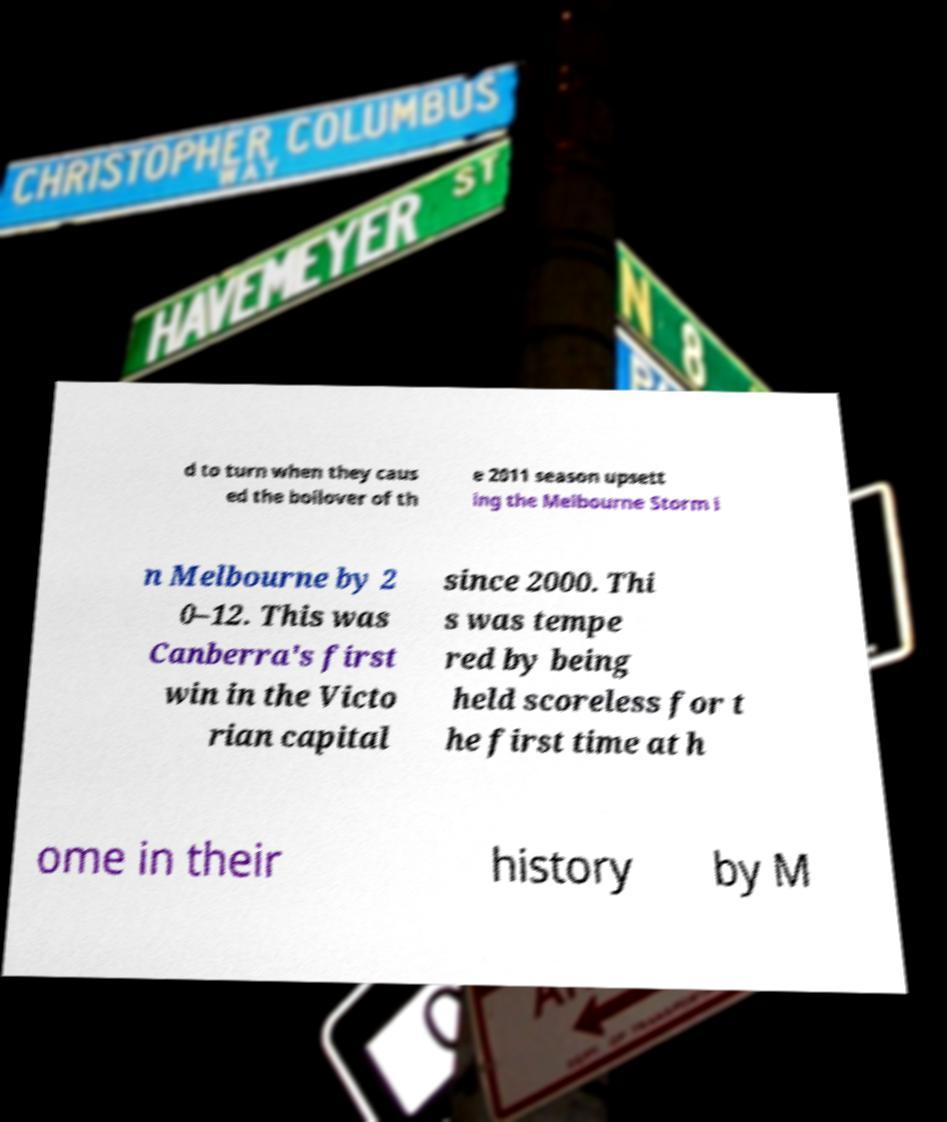Could you assist in decoding the text presented in this image and type it out clearly? d to turn when they caus ed the boilover of th e 2011 season upsett ing the Melbourne Storm i n Melbourne by 2 0–12. This was Canberra's first win in the Victo rian capital since 2000. Thi s was tempe red by being held scoreless for t he first time at h ome in their history by M 